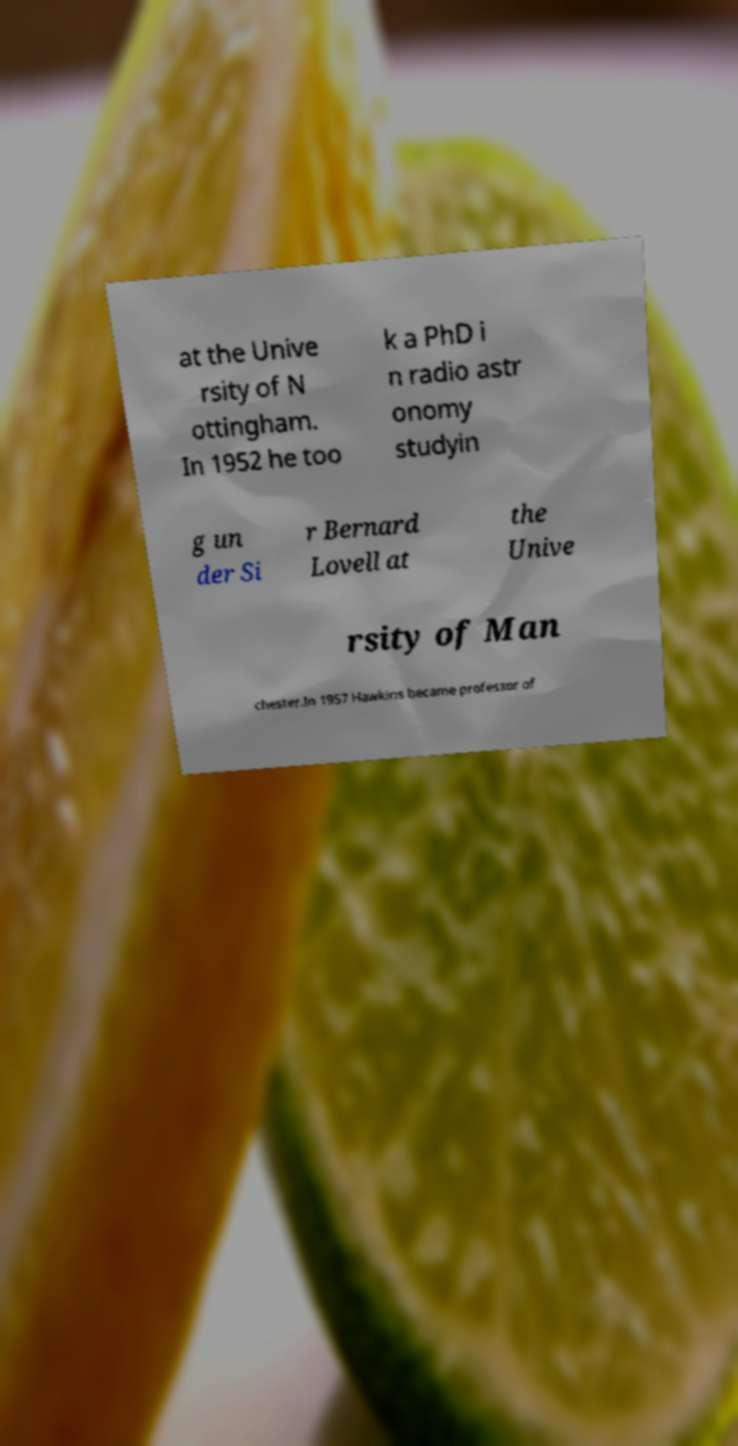Please read and relay the text visible in this image. What does it say? at the Unive rsity of N ottingham. In 1952 he too k a PhD i n radio astr onomy studyin g un der Si r Bernard Lovell at the Unive rsity of Man chester.In 1957 Hawkins became professor of 